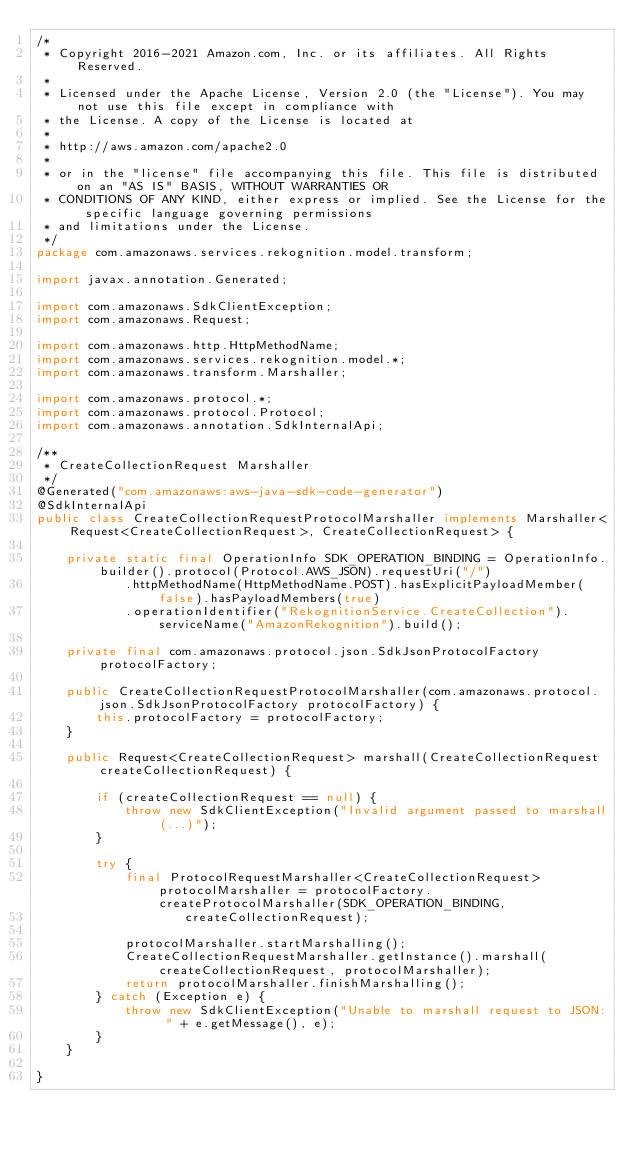<code> <loc_0><loc_0><loc_500><loc_500><_Java_>/*
 * Copyright 2016-2021 Amazon.com, Inc. or its affiliates. All Rights Reserved.
 * 
 * Licensed under the Apache License, Version 2.0 (the "License"). You may not use this file except in compliance with
 * the License. A copy of the License is located at
 * 
 * http://aws.amazon.com/apache2.0
 * 
 * or in the "license" file accompanying this file. This file is distributed on an "AS IS" BASIS, WITHOUT WARRANTIES OR
 * CONDITIONS OF ANY KIND, either express or implied. See the License for the specific language governing permissions
 * and limitations under the License.
 */
package com.amazonaws.services.rekognition.model.transform;

import javax.annotation.Generated;

import com.amazonaws.SdkClientException;
import com.amazonaws.Request;

import com.amazonaws.http.HttpMethodName;
import com.amazonaws.services.rekognition.model.*;
import com.amazonaws.transform.Marshaller;

import com.amazonaws.protocol.*;
import com.amazonaws.protocol.Protocol;
import com.amazonaws.annotation.SdkInternalApi;

/**
 * CreateCollectionRequest Marshaller
 */
@Generated("com.amazonaws:aws-java-sdk-code-generator")
@SdkInternalApi
public class CreateCollectionRequestProtocolMarshaller implements Marshaller<Request<CreateCollectionRequest>, CreateCollectionRequest> {

    private static final OperationInfo SDK_OPERATION_BINDING = OperationInfo.builder().protocol(Protocol.AWS_JSON).requestUri("/")
            .httpMethodName(HttpMethodName.POST).hasExplicitPayloadMember(false).hasPayloadMembers(true)
            .operationIdentifier("RekognitionService.CreateCollection").serviceName("AmazonRekognition").build();

    private final com.amazonaws.protocol.json.SdkJsonProtocolFactory protocolFactory;

    public CreateCollectionRequestProtocolMarshaller(com.amazonaws.protocol.json.SdkJsonProtocolFactory protocolFactory) {
        this.protocolFactory = protocolFactory;
    }

    public Request<CreateCollectionRequest> marshall(CreateCollectionRequest createCollectionRequest) {

        if (createCollectionRequest == null) {
            throw new SdkClientException("Invalid argument passed to marshall(...)");
        }

        try {
            final ProtocolRequestMarshaller<CreateCollectionRequest> protocolMarshaller = protocolFactory.createProtocolMarshaller(SDK_OPERATION_BINDING,
                    createCollectionRequest);

            protocolMarshaller.startMarshalling();
            CreateCollectionRequestMarshaller.getInstance().marshall(createCollectionRequest, protocolMarshaller);
            return protocolMarshaller.finishMarshalling();
        } catch (Exception e) {
            throw new SdkClientException("Unable to marshall request to JSON: " + e.getMessage(), e);
        }
    }

}
</code> 